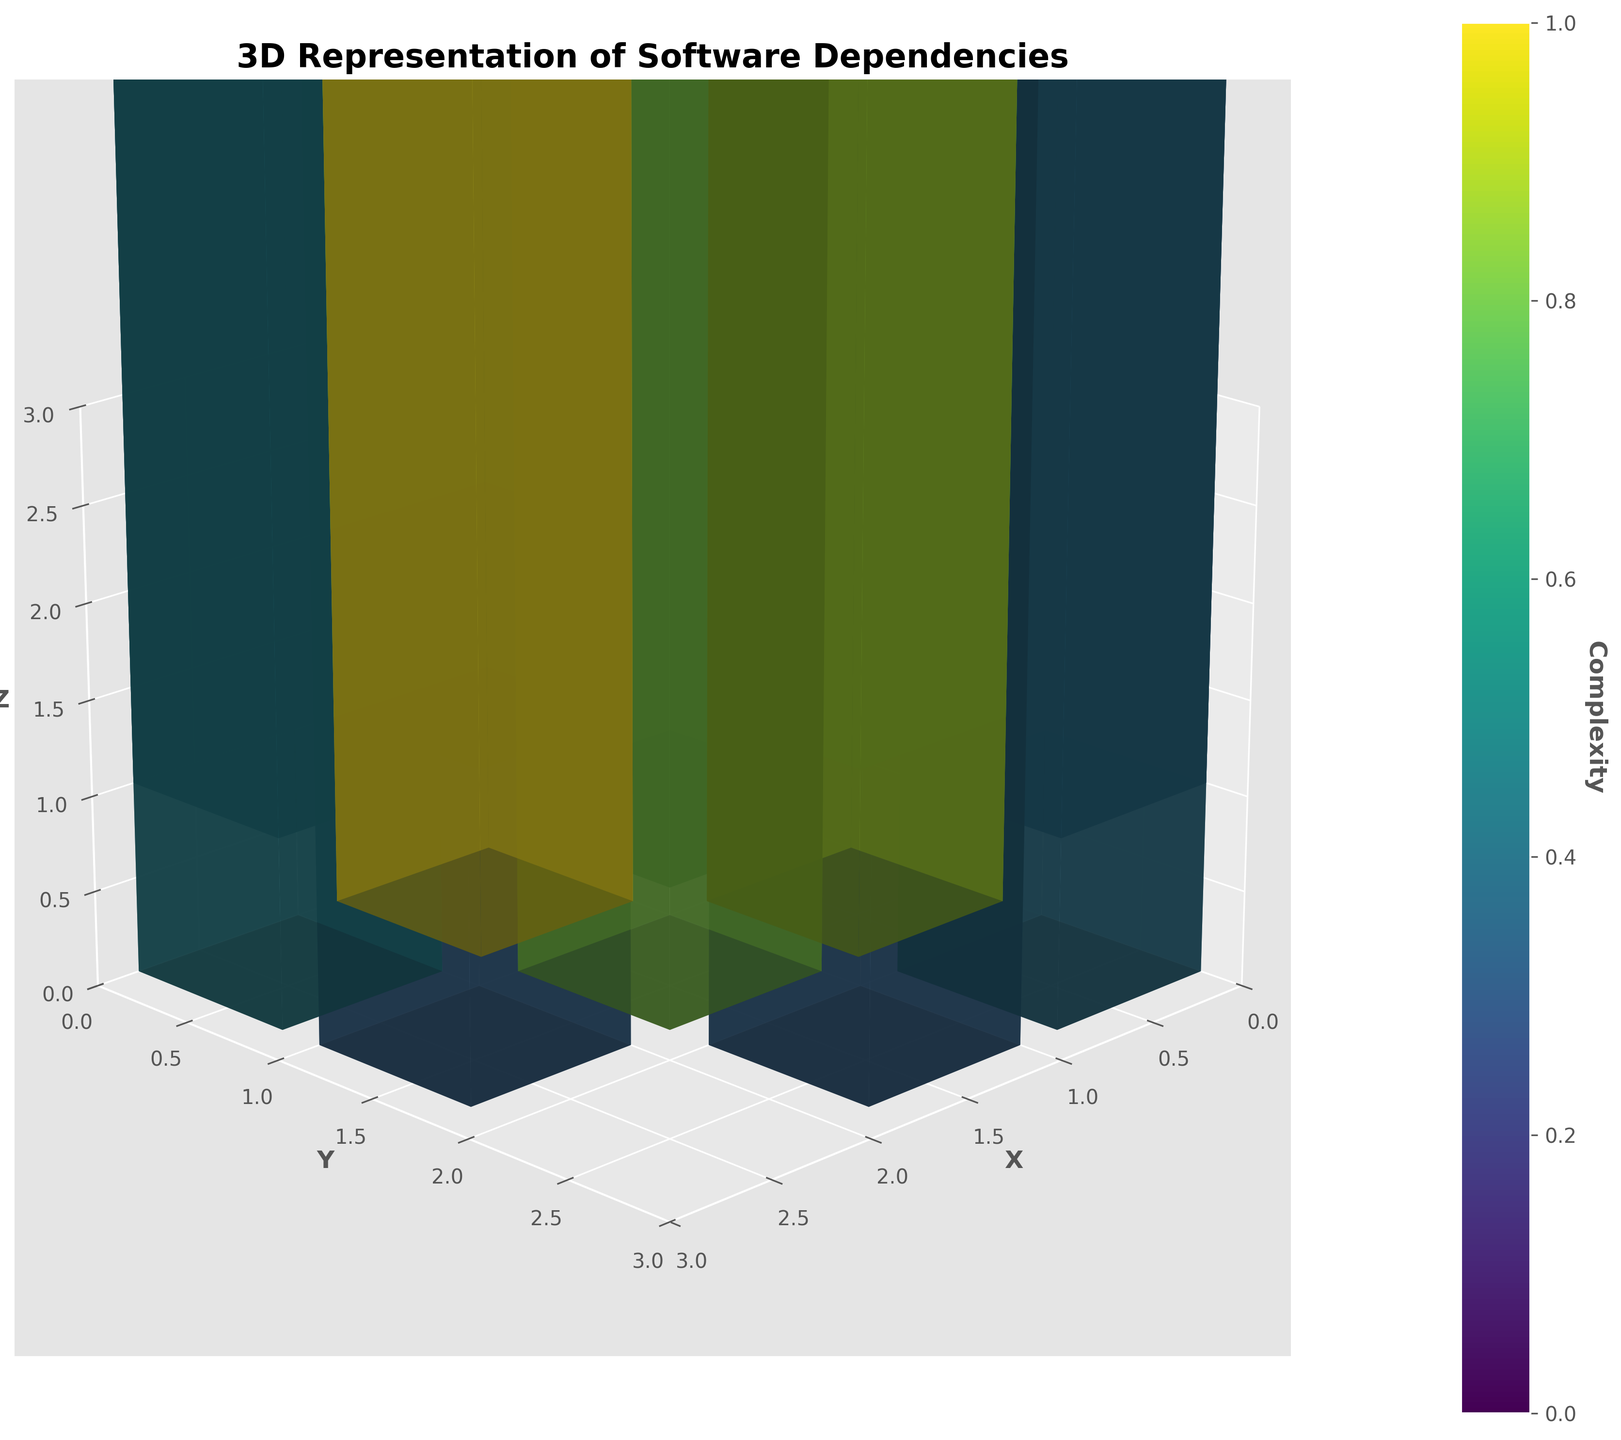Which module has the highest complexity? The bar representing 'IfcOpenShell' has the largest size, indicating it has the highest complexity.
Answer: IfcOpenShell What is the title of the plot? The title of the plot is displayed at the top.
Answer: 3D Representation of Software Dependencies How many modules are represented in the plot? By counting the number of unique modules in the figure labels, we see there are 17 modules represented.
Answer: 17 Which axis represents the complexity of the modules? The Z-axis, which is labeled 'Complexity,' indicates the complexity of the modules.
Answer: Z-axis Compare the complexity of the 'main' module and the 'numpy' module. Which one is more complex? The 'main' module has a smaller bar compared to the 'numpy' module, indicating that 'numpy' has a higher complexity.
Answer: numpy What is the average complexity of the modules with their Z-coordinate equal to 1? First, identify the modules with z=1: matplotlib, data_processing, geometry_utils, ifc_parser, unit_converter, and logger. Their complexities are 55, 45, 40, 60, 30, and 20, respectively. The average is calculated as (55 + 45 + 40 + 60 + 30 + 20)/6 = 250/6 = 41.67.
Answer: 41.67 What are the modules located at (2,0,0) and (2,1,0)? The modules 'visualization' and 'config_manager' are located at (2,0,0) and (2,1,0) respectively.
Answer: visualization, config_manager Which module has the smallest complexity and what is its value? The module 'logger' has the smallest bar size, indicating the lowest complexity which is 20.
Answer: logger, 20 Is the complexity of 'spatial_index' greater than 'mesh_generator'? By comparing the bar heights, 'spatial_index' has a complexity smaller than 'mesh_generator' (50 vs. 55).
Answer: No 